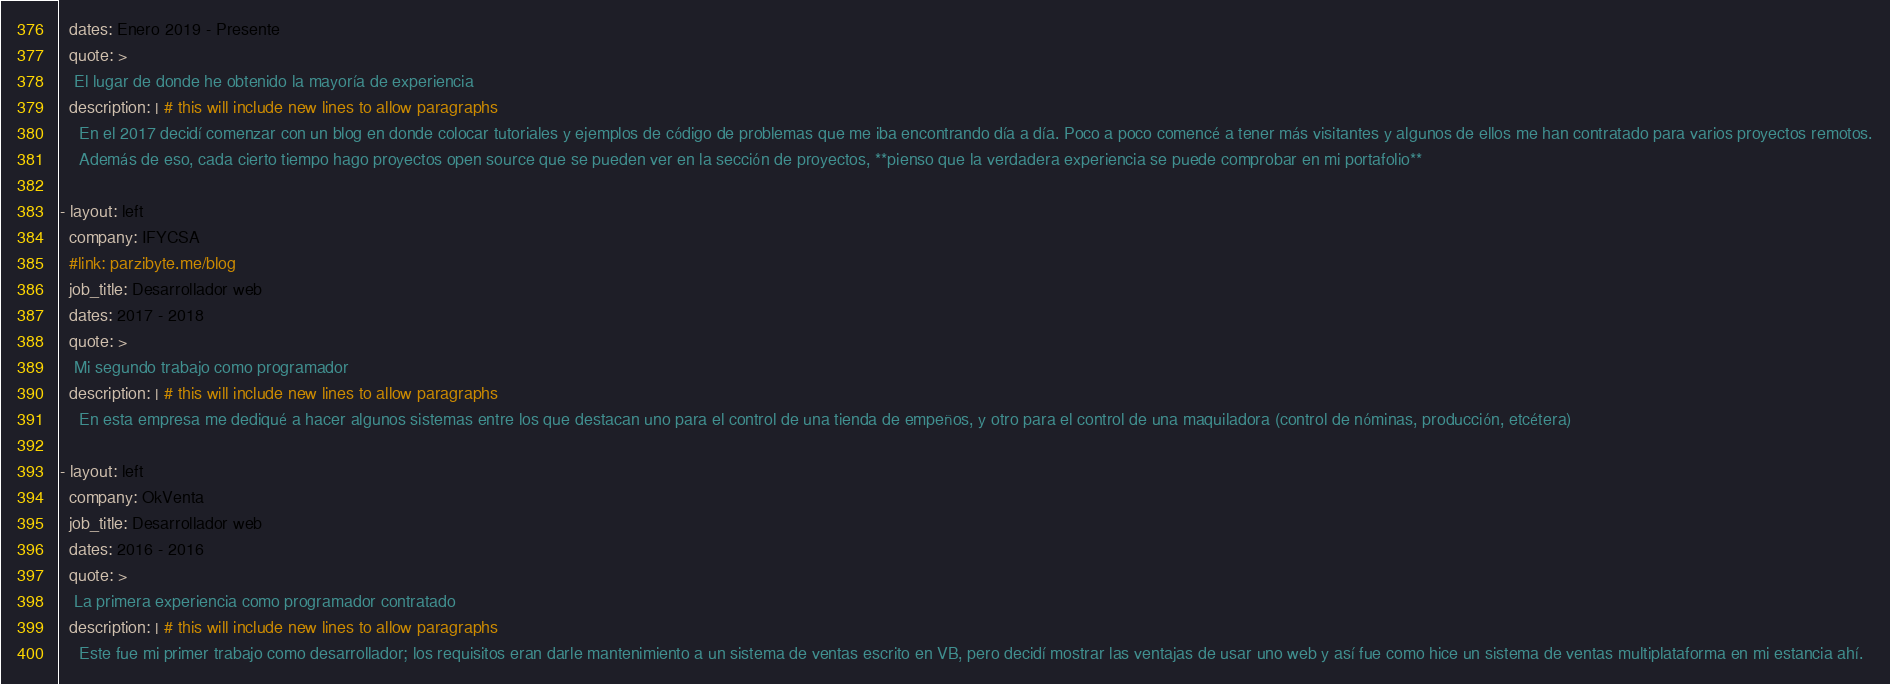Convert code to text. <code><loc_0><loc_0><loc_500><loc_500><_YAML_>  dates: Enero 2019 - Presente
  quote: >
   El lugar de donde he obtenido la mayoría de experiencia
  description: | # this will include new lines to allow paragraphs
    En el 2017 decidí comenzar con un blog en donde colocar tutoriales y ejemplos de código de problemas que me iba encontrando día a día. Poco a poco comencé a tener más visitantes y algunos de ellos me han contratado para varios proyectos remotos.
    Además de eso, cada cierto tiempo hago proyectos open source que se pueden ver en la sección de proyectos, **pienso que la verdadera experiencia se puede comprobar en mi portafolio**

- layout: left
  company: IFYCSA
  #link: parzibyte.me/blog
  job_title: Desarrollador web
  dates: 2017 - 2018
  quote: >
   Mi segundo trabajo como programador
  description: | # this will include new lines to allow paragraphs
    En esta empresa me dediqué a hacer algunos sistemas entre los que destacan uno para el control de una tienda de empeños, y otro para el control de una maquiladora (control de nóminas, producción, etcétera)

- layout: left
  company: OkVenta
  job_title: Desarrollador web
  dates: 2016 - 2016
  quote: >
   La primera experiencia como programador contratado
  description: | # this will include new lines to allow paragraphs
    Este fue mi primer trabajo como desarrollador; los requisitos eran darle mantenimiento a un sistema de ventas escrito en VB, pero decidí mostrar las ventajas de usar uno web y así fue como hice un sistema de ventas multiplataforma en mi estancia ahí.</code> 